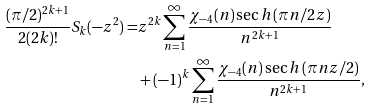Convert formula to latex. <formula><loc_0><loc_0><loc_500><loc_500>\frac { ( \pi / 2 ) ^ { 2 k + 1 } } { 2 ( 2 k ) ! } S _ { k } ( - z ^ { 2 } ) = & z ^ { 2 k } \sum _ { n = 1 } ^ { \infty } \frac { \chi _ { - 4 } ( n ) \sec h \left ( \pi n / 2 z \right ) } { n ^ { 2 k + 1 } } \\ & + ( - 1 ) ^ { k } \sum _ { n = 1 } ^ { \infty } \frac { \chi _ { - 4 } ( n ) \sec h \left ( \pi n z / 2 \right ) } { n ^ { 2 k + 1 } } ,</formula> 